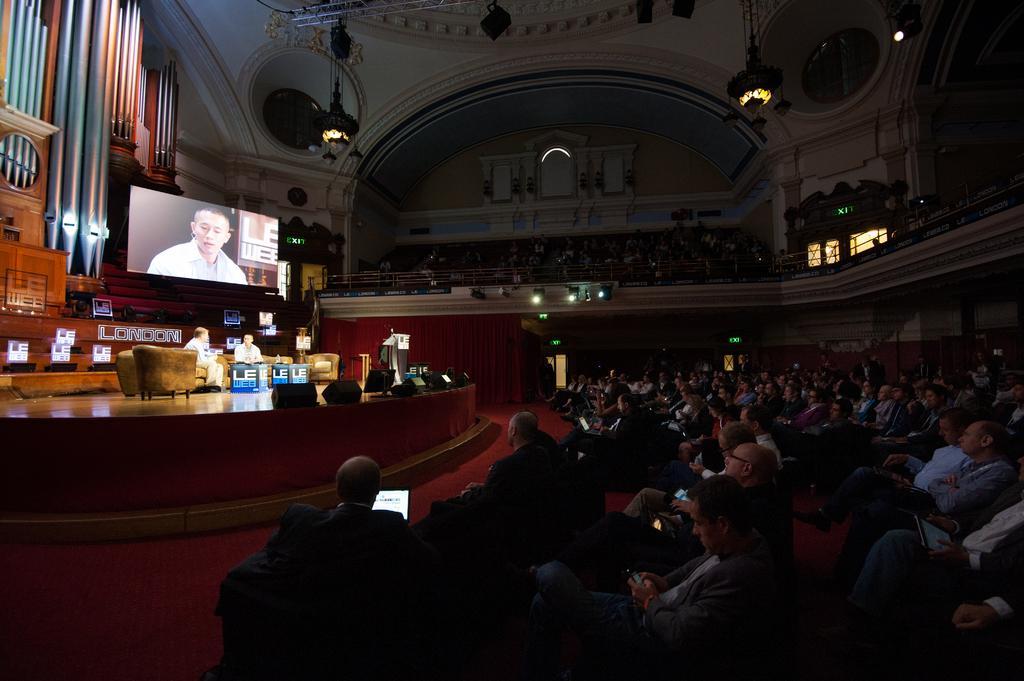How would you summarize this image in a sentence or two? This picture shows the inner view of a building. There are some lights attached to the ceiling, dome lights attached to the wall, four exit boards are near to the doors, one podium with microphone, so many objects are on the surface and one fence. So many people are sitting on chairs and holding so objects. Two people are sitting on Dias, one carpet on the floor, one projector screen, so many chairs are there. 